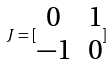<formula> <loc_0><loc_0><loc_500><loc_500>J = [ \begin{matrix} 0 & 1 \\ - 1 & 0 \end{matrix} ]</formula> 